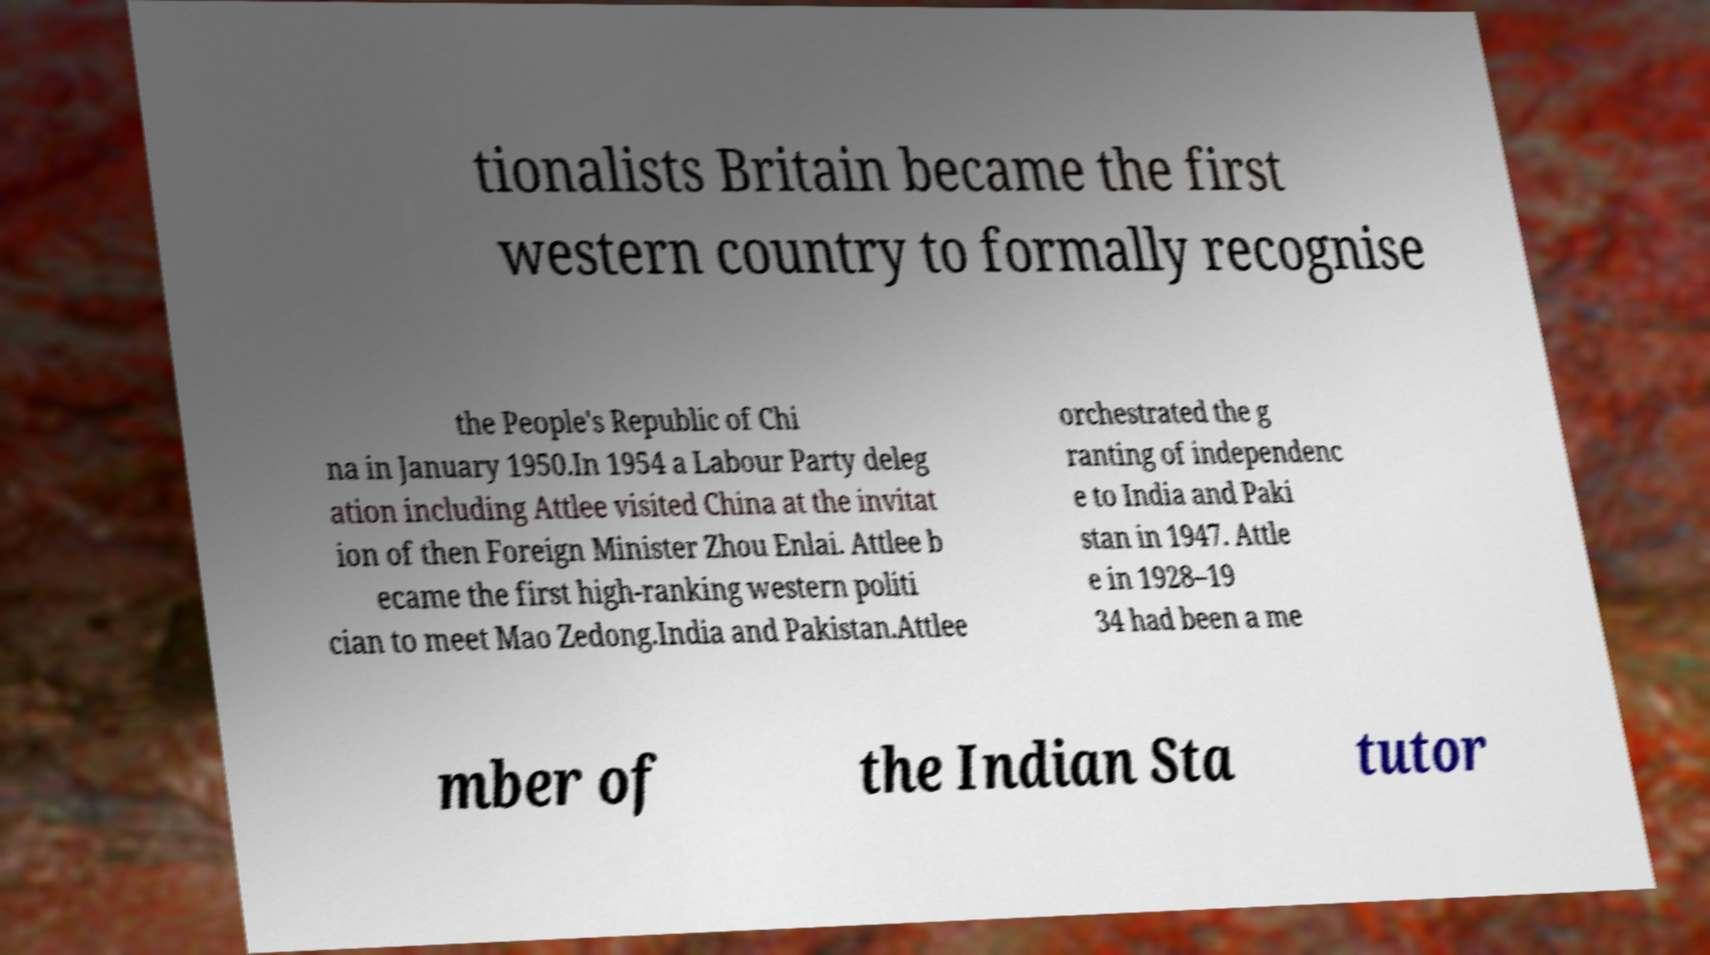Can you accurately transcribe the text from the provided image for me? tionalists Britain became the first western country to formally recognise the People's Republic of Chi na in January 1950.In 1954 a Labour Party deleg ation including Attlee visited China at the invitat ion of then Foreign Minister Zhou Enlai. Attlee b ecame the first high-ranking western politi cian to meet Mao Zedong.India and Pakistan.Attlee orchestrated the g ranting of independenc e to India and Paki stan in 1947. Attle e in 1928–19 34 had been a me mber of the Indian Sta tutor 